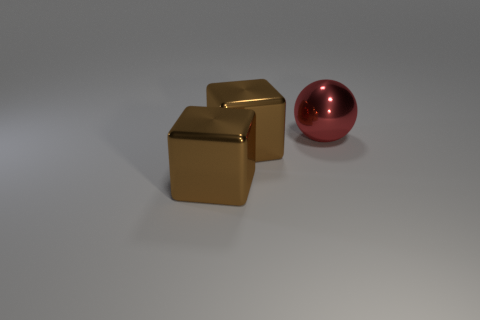How many objects have the same material as the big ball?
Your answer should be very brief. 2. How many objects are big metal things that are in front of the sphere or shiny spheres?
Provide a succinct answer. 3. What number of large things are either red spheres or shiny cubes?
Offer a terse response. 3. Is the number of red metal spheres less than the number of blue metal spheres?
Offer a terse response. No. Is the number of large red metallic objects greater than the number of large metallic things?
Provide a short and direct response. No. What number of other objects are the same color as the ball?
Offer a terse response. 0. Are there any shiny things to the left of the big red metallic object?
Offer a terse response. Yes. How big is the metal sphere?
Your answer should be compact. Large. What number of large cyan cylinders are there?
Ensure brevity in your answer.  0. Are there any brown cubes that have the same size as the red ball?
Your answer should be very brief. Yes. 